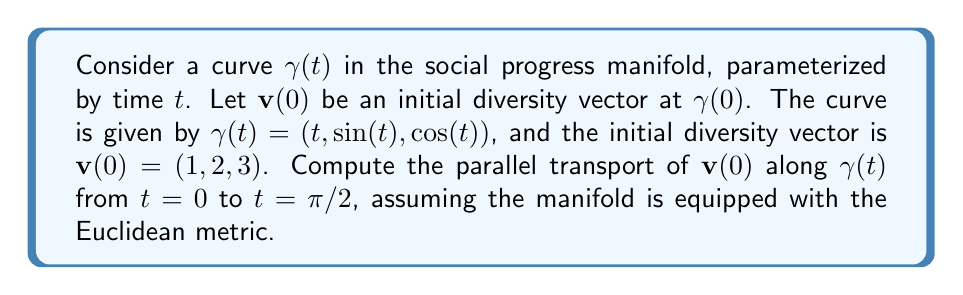Show me your answer to this math problem. To solve this problem, we'll follow these steps:

1) In Euclidean space with the standard metric, parallel transport preserves the components of a vector relative to the coordinate basis. This means we need to solve the parallel transport equation:

   $$\frac{D\mathbf{v}}{dt} = 0$$

2) In component form, this equation becomes:

   $$\frac{dv^i}{dt} + \Gamma^i_{jk}\frac{d\gamma^j}{dt}v^k = 0$$

   where $\Gamma^i_{jk}$ are the Christoffel symbols.

3) In Euclidean space, all Christoffel symbols are zero. Therefore, our equation simplifies to:

   $$\frac{dv^i}{dt} = 0$$

4) This means that each component of $\mathbf{v}(t)$ remains constant along the curve. So:

   $$\mathbf{v}(t) = \mathbf{v}(0) = (1, 2, 3)$$

5) The parallel transport from $t=0$ to $t=\pi/2$ is simply:

   $$\mathbf{v}(\pi/2) = (1, 2, 3)$$

This result indicates that in the context of our social progress manifold with Euclidean metric, the components of the diversity vector remain unchanged as we move along the curve of social progress.
Answer: $\mathbf{v}(\pi/2) = (1, 2, 3)$ 